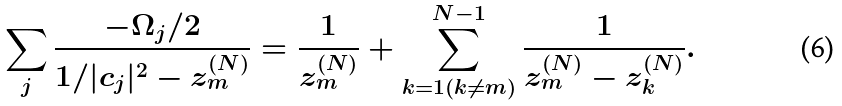<formula> <loc_0><loc_0><loc_500><loc_500>\sum _ { j } \frac { - \Omega _ { j } / 2 } { 1 / | c _ { j } | ^ { 2 } - z ^ { ( N ) } _ { m } } = \frac { 1 } { z ^ { ( N ) } _ { m } } + \sum _ { k = 1 ( k \neq m ) } ^ { N - 1 } \frac { 1 } { z ^ { ( N ) } _ { m } - z ^ { ( N ) } _ { k } } .</formula> 